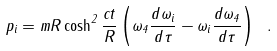<formula> <loc_0><loc_0><loc_500><loc_500>p _ { i } = m R \cosh ^ { 2 } \frac { c t } R \left ( \omega _ { 4 } \frac { d \omega _ { i } } { d \tau } - \omega _ { i } \frac { d \omega _ { 4 } } { d \tau } \right ) \ .</formula> 